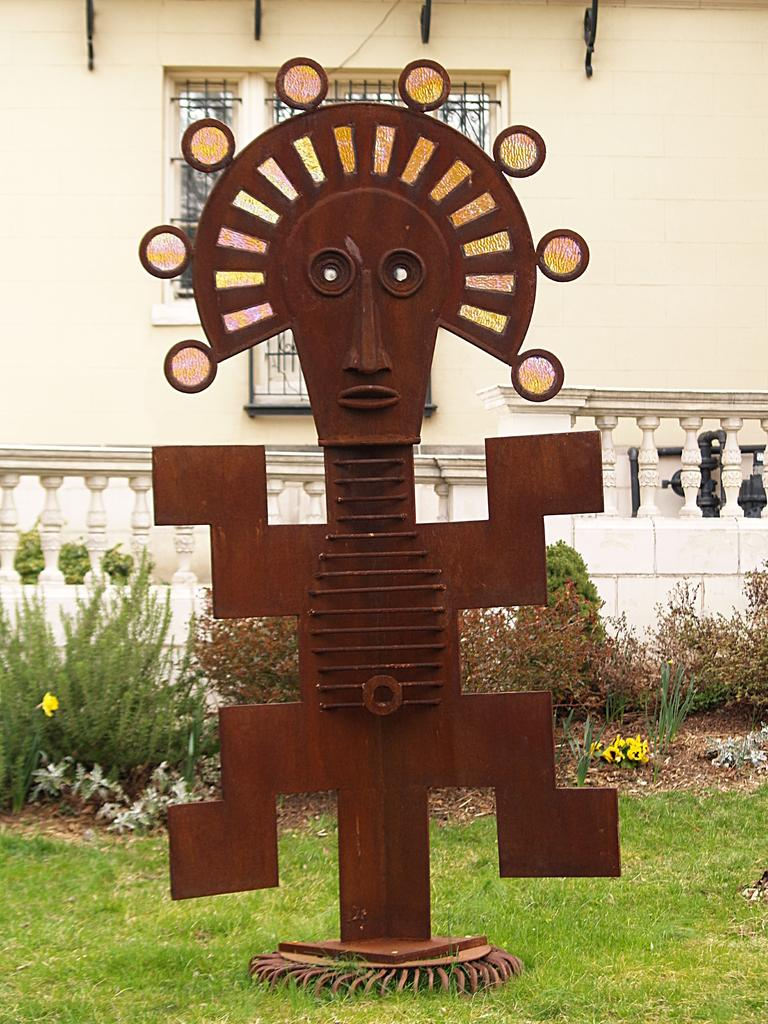What is located in the middle of the grassland in the image? There is a statue in the middle of the grassland. What can be seen behind the statue? There are plants behind the statue. What is located behind the plants? There is a fence behind the plants. What is situated behind the fence? There is a wall behind the fence. Can you describe a specific feature of the wall? There is a window in the middle of the wall. What type of blood is visible on the statue in the image? There is no blood visible on the statue in the image. Is there a beggar sitting near the statue in the image? There is no beggar present in the image. 